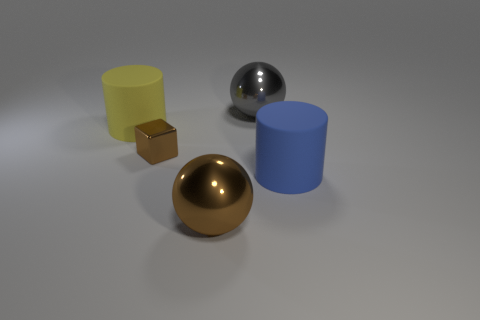Is there any other thing that has the same size as the cube?
Provide a succinct answer. No. What is the size of the yellow thing that is the same shape as the blue object?
Keep it short and to the point. Large. Is the number of large gray balls greater than the number of large objects?
Provide a short and direct response. No. Do the large yellow object and the blue rubber object have the same shape?
Offer a terse response. Yes. What is the material of the big yellow cylinder that is behind the big object that is to the right of the gray sphere?
Your answer should be very brief. Rubber. What is the material of the object that is the same color as the cube?
Make the answer very short. Metal. Do the yellow object and the cube have the same size?
Offer a very short reply. No. Are there any yellow cylinders that are in front of the brown thing behind the brown ball?
Ensure brevity in your answer.  No. There is a large thing that is on the left side of the brown sphere; what shape is it?
Offer a very short reply. Cylinder. How many big metallic things are in front of the rubber cylinder left of the large metallic object that is right of the big brown metallic thing?
Give a very brief answer. 1. 